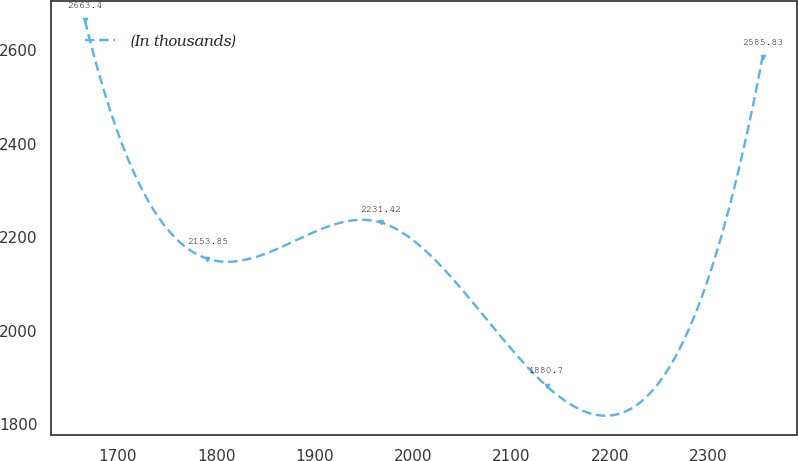<chart> <loc_0><loc_0><loc_500><loc_500><line_chart><ecel><fcel>(In thousands)<nl><fcel>1666.72<fcel>2663.4<nl><fcel>1790.98<fcel>2153.85<nl><fcel>1967.05<fcel>2231.42<nl><fcel>2135.87<fcel>1880.7<nl><fcel>2354.86<fcel>2585.83<nl></chart> 